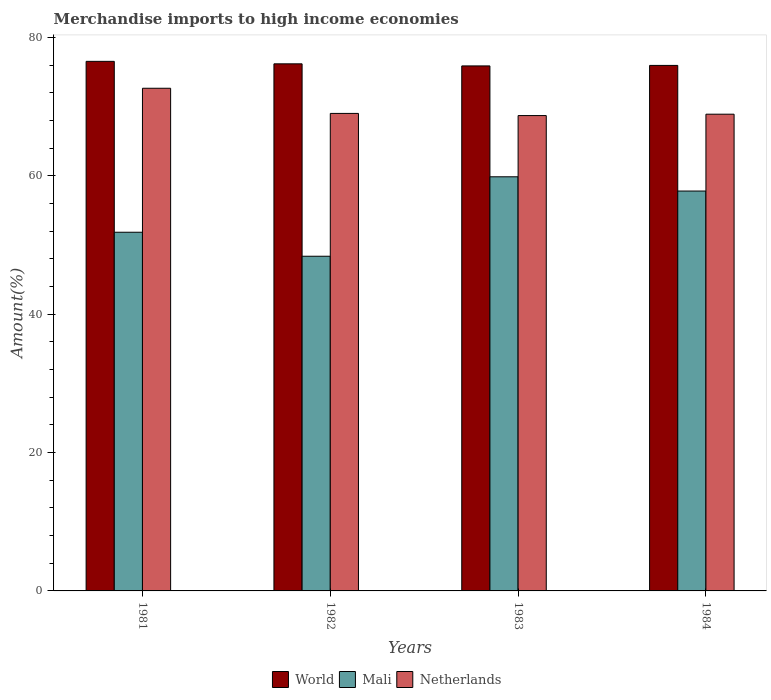How many different coloured bars are there?
Provide a short and direct response. 3. How many bars are there on the 3rd tick from the left?
Keep it short and to the point. 3. How many bars are there on the 4th tick from the right?
Your answer should be compact. 3. In how many cases, is the number of bars for a given year not equal to the number of legend labels?
Your response must be concise. 0. What is the percentage of amount earned from merchandise imports in World in 1983?
Give a very brief answer. 75.88. Across all years, what is the maximum percentage of amount earned from merchandise imports in World?
Keep it short and to the point. 76.54. Across all years, what is the minimum percentage of amount earned from merchandise imports in Netherlands?
Give a very brief answer. 68.71. In which year was the percentage of amount earned from merchandise imports in Mali maximum?
Keep it short and to the point. 1983. What is the total percentage of amount earned from merchandise imports in World in the graph?
Provide a short and direct response. 304.57. What is the difference between the percentage of amount earned from merchandise imports in Mali in 1981 and that in 1983?
Make the answer very short. -8.01. What is the difference between the percentage of amount earned from merchandise imports in World in 1983 and the percentage of amount earned from merchandise imports in Netherlands in 1984?
Make the answer very short. 6.98. What is the average percentage of amount earned from merchandise imports in Mali per year?
Give a very brief answer. 54.47. In the year 1984, what is the difference between the percentage of amount earned from merchandise imports in Netherlands and percentage of amount earned from merchandise imports in World?
Offer a very short reply. -7.05. What is the ratio of the percentage of amount earned from merchandise imports in Mali in 1983 to that in 1984?
Provide a short and direct response. 1.04. Is the percentage of amount earned from merchandise imports in Mali in 1981 less than that in 1983?
Give a very brief answer. Yes. What is the difference between the highest and the second highest percentage of amount earned from merchandise imports in Netherlands?
Give a very brief answer. 3.64. What is the difference between the highest and the lowest percentage of amount earned from merchandise imports in Netherlands?
Provide a short and direct response. 3.95. What does the 2nd bar from the left in 1982 represents?
Ensure brevity in your answer.  Mali. Are all the bars in the graph horizontal?
Make the answer very short. No. How many years are there in the graph?
Ensure brevity in your answer.  4. What is the difference between two consecutive major ticks on the Y-axis?
Your response must be concise. 20. Does the graph contain grids?
Your answer should be compact. No. Where does the legend appear in the graph?
Make the answer very short. Bottom center. What is the title of the graph?
Your answer should be very brief. Merchandise imports to high income economies. What is the label or title of the X-axis?
Keep it short and to the point. Years. What is the label or title of the Y-axis?
Provide a succinct answer. Amount(%). What is the Amount(%) in World in 1981?
Give a very brief answer. 76.54. What is the Amount(%) in Mali in 1981?
Your response must be concise. 51.84. What is the Amount(%) of Netherlands in 1981?
Offer a terse response. 72.65. What is the Amount(%) of World in 1982?
Make the answer very short. 76.19. What is the Amount(%) of Mali in 1982?
Provide a succinct answer. 48.37. What is the Amount(%) of Netherlands in 1982?
Provide a succinct answer. 69.02. What is the Amount(%) in World in 1983?
Offer a terse response. 75.88. What is the Amount(%) in Mali in 1983?
Keep it short and to the point. 59.86. What is the Amount(%) of Netherlands in 1983?
Ensure brevity in your answer.  68.71. What is the Amount(%) of World in 1984?
Your response must be concise. 75.96. What is the Amount(%) of Mali in 1984?
Ensure brevity in your answer.  57.8. What is the Amount(%) of Netherlands in 1984?
Provide a succinct answer. 68.91. Across all years, what is the maximum Amount(%) in World?
Your response must be concise. 76.54. Across all years, what is the maximum Amount(%) of Mali?
Keep it short and to the point. 59.86. Across all years, what is the maximum Amount(%) in Netherlands?
Give a very brief answer. 72.65. Across all years, what is the minimum Amount(%) of World?
Your answer should be very brief. 75.88. Across all years, what is the minimum Amount(%) of Mali?
Your response must be concise. 48.37. Across all years, what is the minimum Amount(%) in Netherlands?
Give a very brief answer. 68.71. What is the total Amount(%) of World in the graph?
Keep it short and to the point. 304.57. What is the total Amount(%) of Mali in the graph?
Your answer should be very brief. 217.87. What is the total Amount(%) of Netherlands in the graph?
Your answer should be very brief. 279.29. What is the difference between the Amount(%) in World in 1981 and that in 1982?
Give a very brief answer. 0.36. What is the difference between the Amount(%) of Mali in 1981 and that in 1982?
Provide a succinct answer. 3.47. What is the difference between the Amount(%) in Netherlands in 1981 and that in 1982?
Make the answer very short. 3.64. What is the difference between the Amount(%) in World in 1981 and that in 1983?
Provide a short and direct response. 0.66. What is the difference between the Amount(%) in Mali in 1981 and that in 1983?
Offer a very short reply. -8.01. What is the difference between the Amount(%) in Netherlands in 1981 and that in 1983?
Your answer should be very brief. 3.95. What is the difference between the Amount(%) in World in 1981 and that in 1984?
Ensure brevity in your answer.  0.59. What is the difference between the Amount(%) of Mali in 1981 and that in 1984?
Make the answer very short. -5.95. What is the difference between the Amount(%) of Netherlands in 1981 and that in 1984?
Make the answer very short. 3.75. What is the difference between the Amount(%) in World in 1982 and that in 1983?
Offer a very short reply. 0.3. What is the difference between the Amount(%) in Mali in 1982 and that in 1983?
Ensure brevity in your answer.  -11.48. What is the difference between the Amount(%) in Netherlands in 1982 and that in 1983?
Make the answer very short. 0.31. What is the difference between the Amount(%) of World in 1982 and that in 1984?
Offer a very short reply. 0.23. What is the difference between the Amount(%) of Mali in 1982 and that in 1984?
Keep it short and to the point. -9.42. What is the difference between the Amount(%) in Netherlands in 1982 and that in 1984?
Provide a succinct answer. 0.11. What is the difference between the Amount(%) of World in 1983 and that in 1984?
Make the answer very short. -0.07. What is the difference between the Amount(%) of Mali in 1983 and that in 1984?
Keep it short and to the point. 2.06. What is the difference between the Amount(%) of Netherlands in 1983 and that in 1984?
Offer a terse response. -0.2. What is the difference between the Amount(%) of World in 1981 and the Amount(%) of Mali in 1982?
Offer a terse response. 28.17. What is the difference between the Amount(%) in World in 1981 and the Amount(%) in Netherlands in 1982?
Keep it short and to the point. 7.53. What is the difference between the Amount(%) in Mali in 1981 and the Amount(%) in Netherlands in 1982?
Keep it short and to the point. -17.17. What is the difference between the Amount(%) in World in 1981 and the Amount(%) in Mali in 1983?
Your answer should be very brief. 16.69. What is the difference between the Amount(%) in World in 1981 and the Amount(%) in Netherlands in 1983?
Offer a terse response. 7.84. What is the difference between the Amount(%) in Mali in 1981 and the Amount(%) in Netherlands in 1983?
Provide a short and direct response. -16.86. What is the difference between the Amount(%) of World in 1981 and the Amount(%) of Mali in 1984?
Your answer should be compact. 18.75. What is the difference between the Amount(%) in World in 1981 and the Amount(%) in Netherlands in 1984?
Provide a succinct answer. 7.64. What is the difference between the Amount(%) of Mali in 1981 and the Amount(%) of Netherlands in 1984?
Your answer should be very brief. -17.06. What is the difference between the Amount(%) in World in 1982 and the Amount(%) in Mali in 1983?
Keep it short and to the point. 16.33. What is the difference between the Amount(%) of World in 1982 and the Amount(%) of Netherlands in 1983?
Your answer should be very brief. 7.48. What is the difference between the Amount(%) in Mali in 1982 and the Amount(%) in Netherlands in 1983?
Offer a very short reply. -20.33. What is the difference between the Amount(%) of World in 1982 and the Amount(%) of Mali in 1984?
Your response must be concise. 18.39. What is the difference between the Amount(%) of World in 1982 and the Amount(%) of Netherlands in 1984?
Provide a short and direct response. 7.28. What is the difference between the Amount(%) in Mali in 1982 and the Amount(%) in Netherlands in 1984?
Your response must be concise. -20.53. What is the difference between the Amount(%) of World in 1983 and the Amount(%) of Mali in 1984?
Ensure brevity in your answer.  18.09. What is the difference between the Amount(%) in World in 1983 and the Amount(%) in Netherlands in 1984?
Offer a very short reply. 6.98. What is the difference between the Amount(%) in Mali in 1983 and the Amount(%) in Netherlands in 1984?
Your answer should be compact. -9.05. What is the average Amount(%) of World per year?
Ensure brevity in your answer.  76.14. What is the average Amount(%) of Mali per year?
Make the answer very short. 54.47. What is the average Amount(%) of Netherlands per year?
Offer a very short reply. 69.82. In the year 1981, what is the difference between the Amount(%) in World and Amount(%) in Mali?
Provide a succinct answer. 24.7. In the year 1981, what is the difference between the Amount(%) in World and Amount(%) in Netherlands?
Give a very brief answer. 3.89. In the year 1981, what is the difference between the Amount(%) of Mali and Amount(%) of Netherlands?
Make the answer very short. -20.81. In the year 1982, what is the difference between the Amount(%) of World and Amount(%) of Mali?
Offer a terse response. 27.81. In the year 1982, what is the difference between the Amount(%) of World and Amount(%) of Netherlands?
Make the answer very short. 7.17. In the year 1982, what is the difference between the Amount(%) in Mali and Amount(%) in Netherlands?
Your answer should be compact. -20.64. In the year 1983, what is the difference between the Amount(%) in World and Amount(%) in Mali?
Your answer should be very brief. 16.03. In the year 1983, what is the difference between the Amount(%) of World and Amount(%) of Netherlands?
Provide a short and direct response. 7.18. In the year 1983, what is the difference between the Amount(%) in Mali and Amount(%) in Netherlands?
Offer a very short reply. -8.85. In the year 1984, what is the difference between the Amount(%) in World and Amount(%) in Mali?
Your answer should be compact. 18.16. In the year 1984, what is the difference between the Amount(%) in World and Amount(%) in Netherlands?
Offer a very short reply. 7.05. In the year 1984, what is the difference between the Amount(%) in Mali and Amount(%) in Netherlands?
Provide a short and direct response. -11.11. What is the ratio of the Amount(%) of Mali in 1981 to that in 1982?
Your answer should be very brief. 1.07. What is the ratio of the Amount(%) in Netherlands in 1981 to that in 1982?
Give a very brief answer. 1.05. What is the ratio of the Amount(%) in World in 1981 to that in 1983?
Your answer should be compact. 1.01. What is the ratio of the Amount(%) in Mali in 1981 to that in 1983?
Your answer should be very brief. 0.87. What is the ratio of the Amount(%) in Netherlands in 1981 to that in 1983?
Offer a terse response. 1.06. What is the ratio of the Amount(%) in World in 1981 to that in 1984?
Offer a very short reply. 1.01. What is the ratio of the Amount(%) in Mali in 1981 to that in 1984?
Make the answer very short. 0.9. What is the ratio of the Amount(%) of Netherlands in 1981 to that in 1984?
Offer a terse response. 1.05. What is the ratio of the Amount(%) in World in 1982 to that in 1983?
Offer a very short reply. 1. What is the ratio of the Amount(%) in Mali in 1982 to that in 1983?
Offer a terse response. 0.81. What is the ratio of the Amount(%) in Mali in 1982 to that in 1984?
Keep it short and to the point. 0.84. What is the ratio of the Amount(%) in Netherlands in 1982 to that in 1984?
Keep it short and to the point. 1. What is the ratio of the Amount(%) in Mali in 1983 to that in 1984?
Keep it short and to the point. 1.04. What is the ratio of the Amount(%) in Netherlands in 1983 to that in 1984?
Offer a terse response. 1. What is the difference between the highest and the second highest Amount(%) in World?
Keep it short and to the point. 0.36. What is the difference between the highest and the second highest Amount(%) of Mali?
Offer a very short reply. 2.06. What is the difference between the highest and the second highest Amount(%) in Netherlands?
Your answer should be very brief. 3.64. What is the difference between the highest and the lowest Amount(%) of World?
Keep it short and to the point. 0.66. What is the difference between the highest and the lowest Amount(%) in Mali?
Offer a very short reply. 11.48. What is the difference between the highest and the lowest Amount(%) of Netherlands?
Provide a short and direct response. 3.95. 